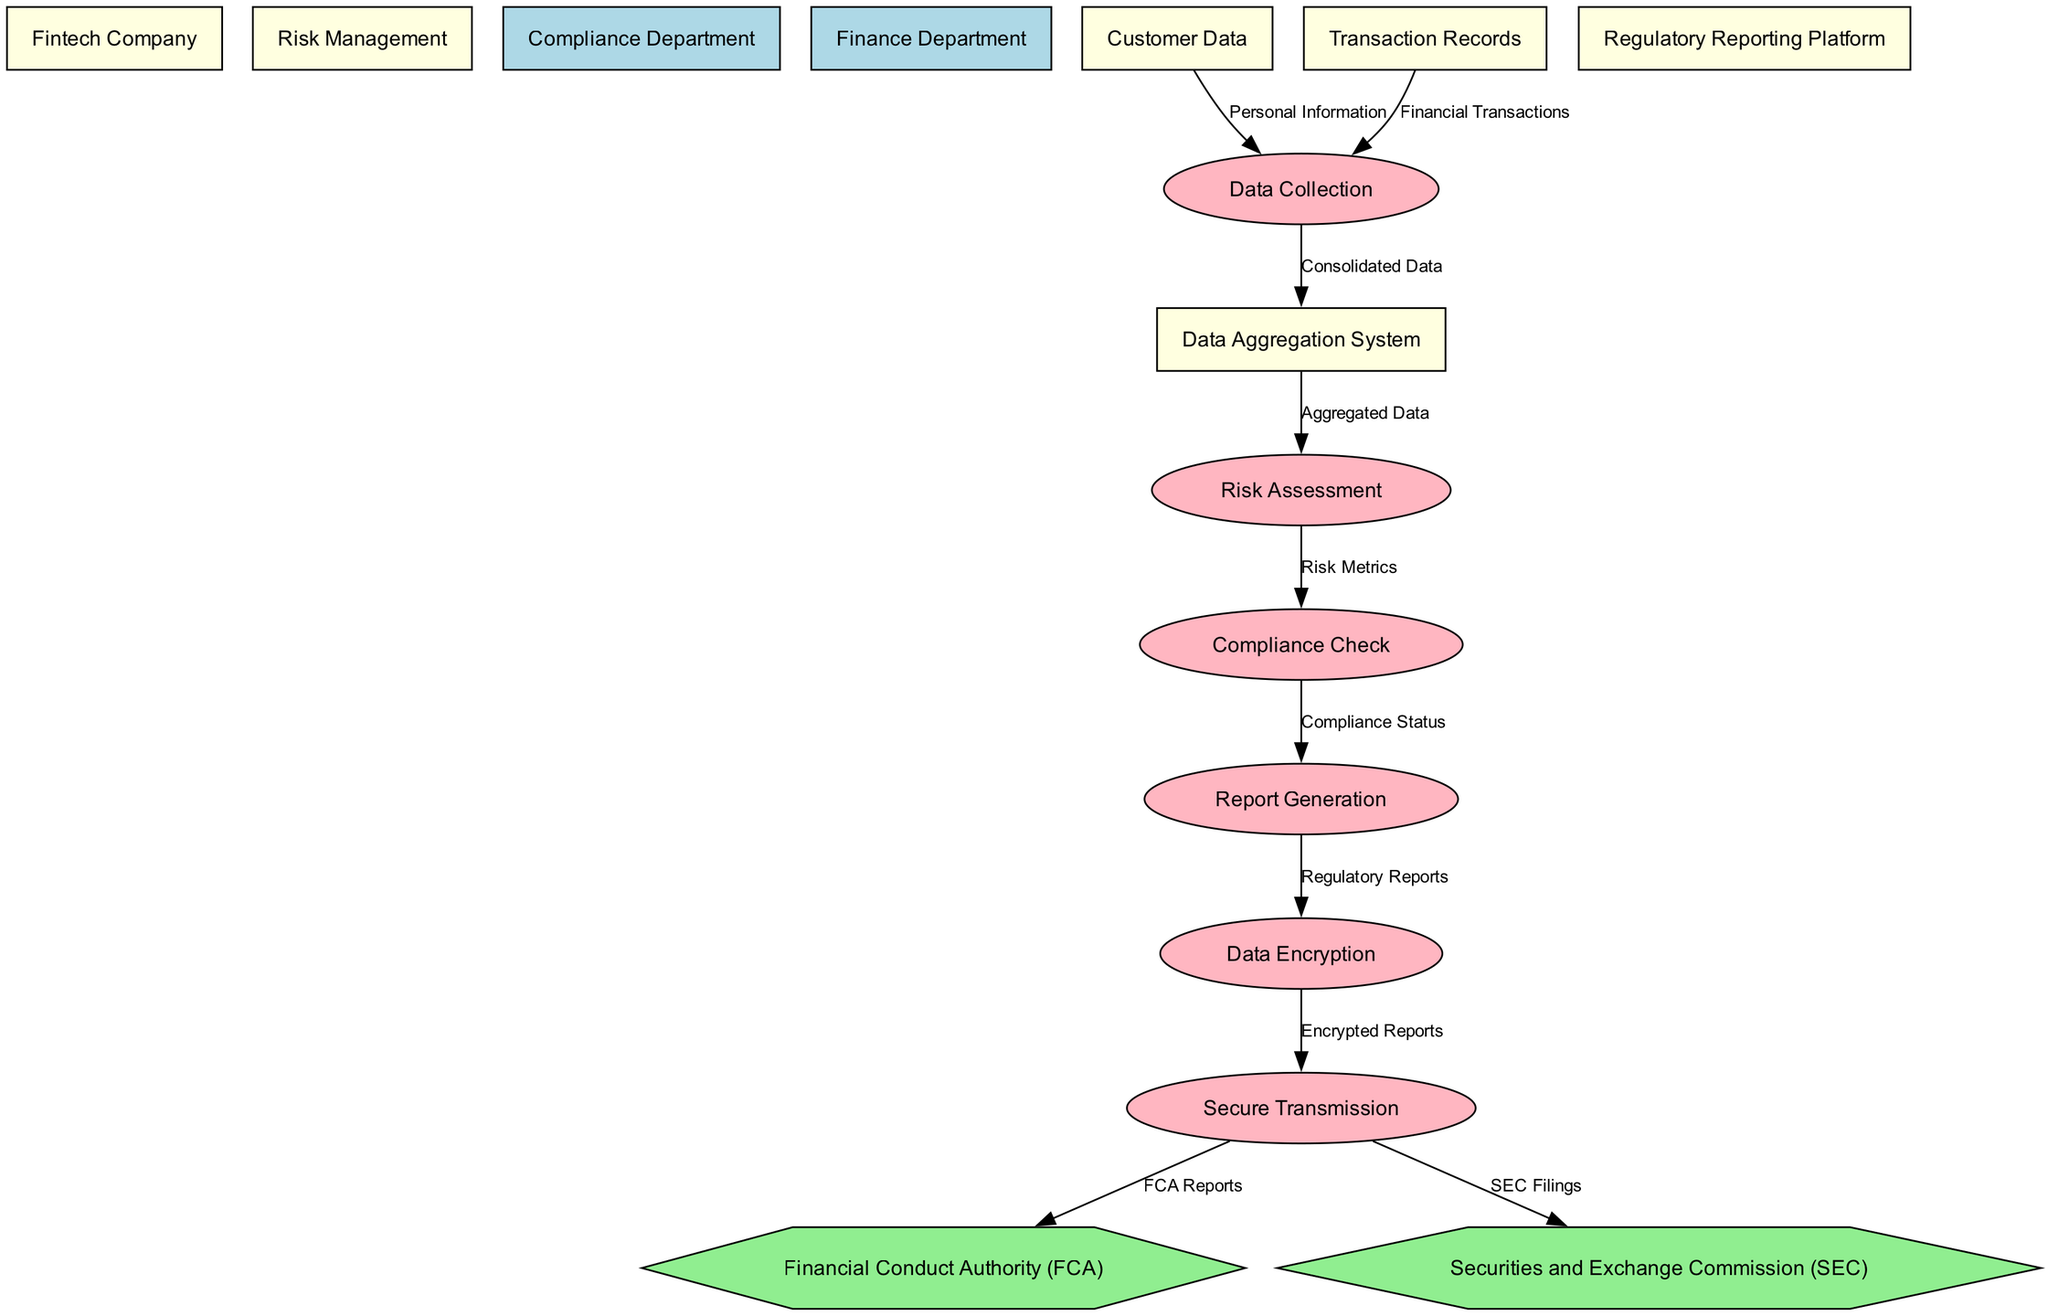What are the two regulatory bodies receiving reports? The diagram shows that the two regulatory bodies receiving reports are the Financial Conduct Authority and the Securities and Exchange Commission. Both are mentioned as destinations at the end of the data flow.
Answer: Financial Conduct Authority, Securities and Exchange Commission How many processes are depicted in the diagram? The diagram contains the following processes: Data Collection, Risk Assessment, Compliance Check, Report Generation, Data Encryption, and Secure Transmission. Counting each listed process results in a total of six processes.
Answer: 6 What is the initial source of data in the compliance reporting system? The diagram indicates that the initial source of data comes from Customer Data, which feeds into the Data Collection process. It is the first entity mentioned in the data flow.
Answer: Customer Data Which department handles the Risk Assessment in the system? According to the diagram, the Risk Management department is responsible for the Risk Assessment process, as depicted by the flow connecting the Data Aggregation System to the Risk Assessment node.
Answer: Risk Management What is the output of the Report Generation process? The output from the Report Generation process is referred to as Regulatory Reports, which is then sent to the Data Encryption process as indicated in the data flows.
Answer: Regulatory Reports Which entity provides Financial Transactions data to the Data Collection process? The diagram specifies that the Transaction Records entity supplies Financial Transactions data to the Data Collection process. This flow represents a key input for compliance reporting.
Answer: Transaction Records What type of data flows securely to the Financial Conduct Authority? The diagram specifies that Encrypted Reports are sent securely to the Financial Conduct Authority, following the Data Encryption and Secure Transmission processes illustrated in the diagram.
Answer: Encrypted Reports Which process follows Compliance Check in the reporting system? The diagram shows that after the Compliance Check, the next process is Report Generation, indicating a sequence where compliance status is transformed into a report for regulatory purposes.
Answer: Report Generation How many entities are involved in the compliance reporting system? The diagram lists a total of ten entities involved in the compliance reporting system: Fintech Company, Risk Management, Compliance Department, Finance Department, Customer Data, Transaction Records, Data Aggregation System, Regulatory Reporting Platform, Financial Conduct Authority, and Securities and Exchange Commission. Counting all these gives a total of ten entities.
Answer: 10 